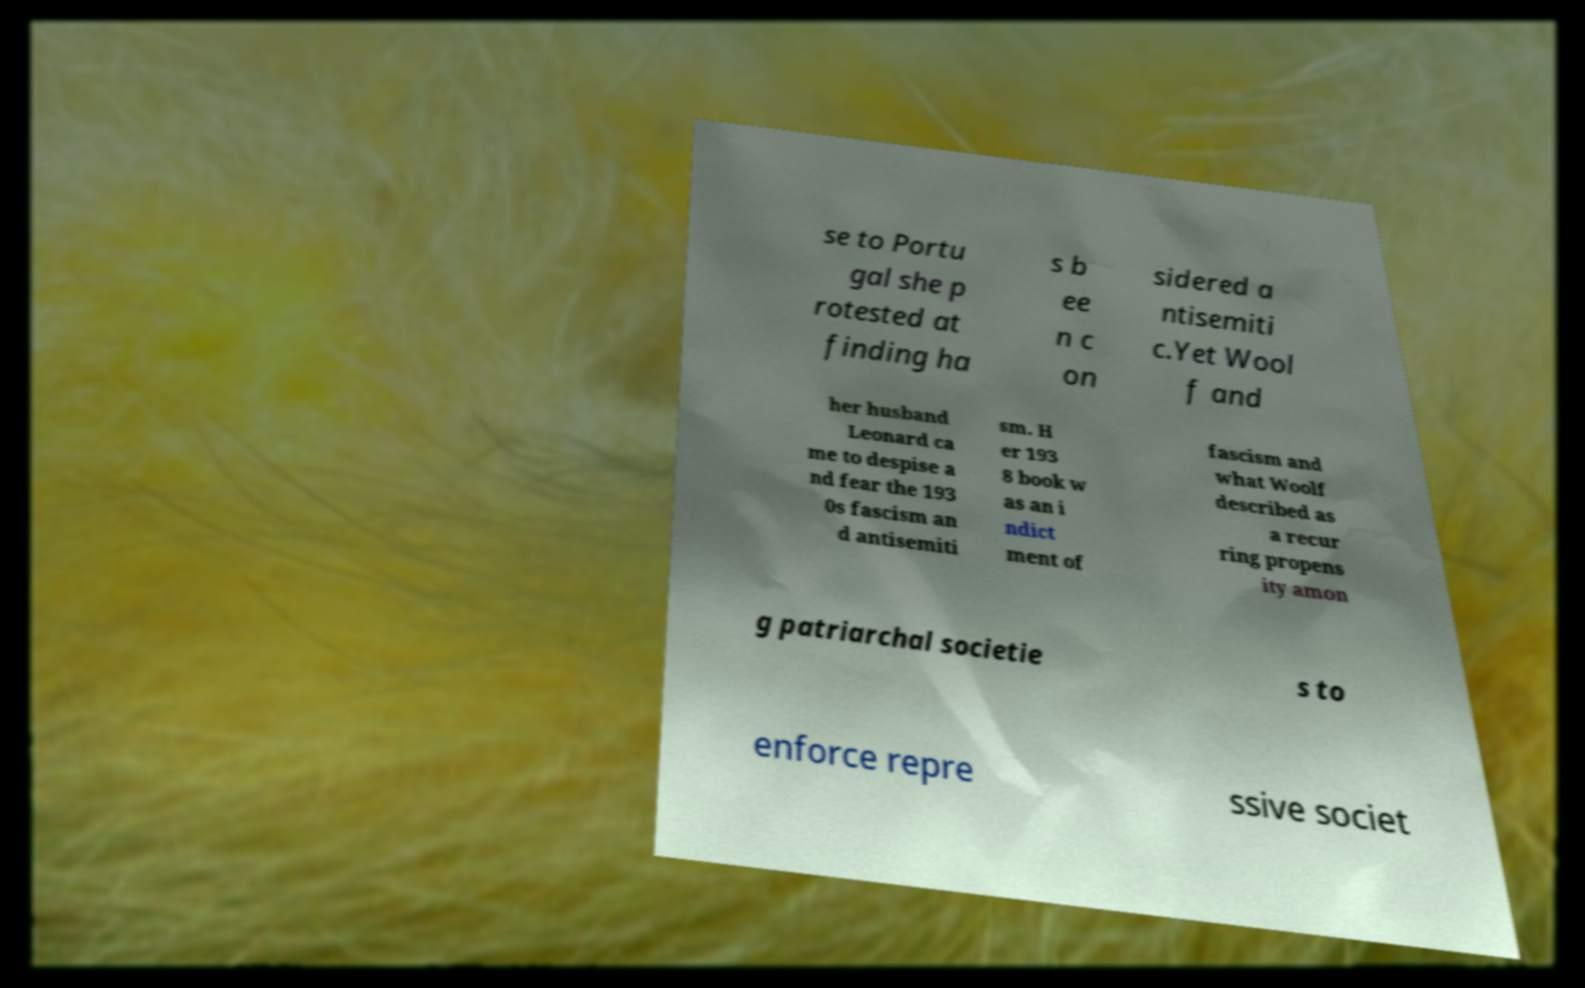For documentation purposes, I need the text within this image transcribed. Could you provide that? se to Portu gal she p rotested at finding ha s b ee n c on sidered a ntisemiti c.Yet Wool f and her husband Leonard ca me to despise a nd fear the 193 0s fascism an d antisemiti sm. H er 193 8 book w as an i ndict ment of fascism and what Woolf described as a recur ring propens ity amon g patriarchal societie s to enforce repre ssive societ 